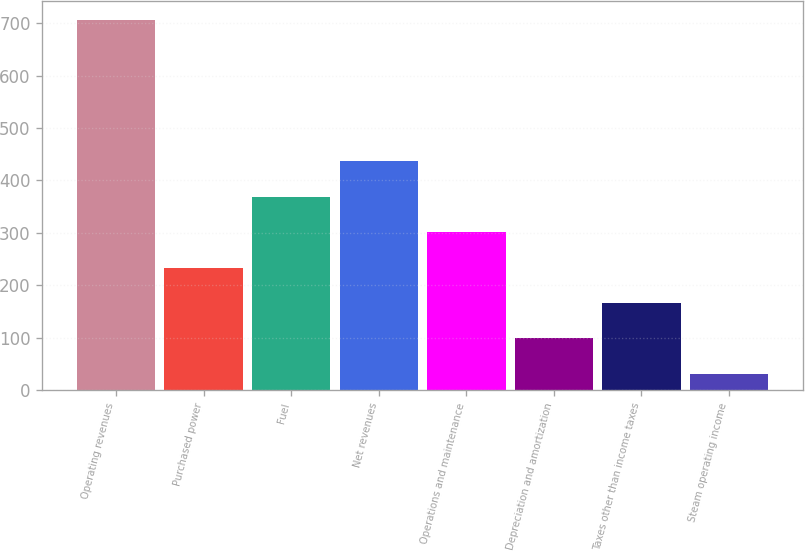Convert chart. <chart><loc_0><loc_0><loc_500><loc_500><bar_chart><fcel>Operating revenues<fcel>Purchased power<fcel>Fuel<fcel>Net revenues<fcel>Operations and maintenance<fcel>Depreciation and amortization<fcel>Taxes other than income taxes<fcel>Steam operating income<nl><fcel>707<fcel>233.8<fcel>369<fcel>436.6<fcel>301.4<fcel>98.6<fcel>166.2<fcel>31<nl></chart> 